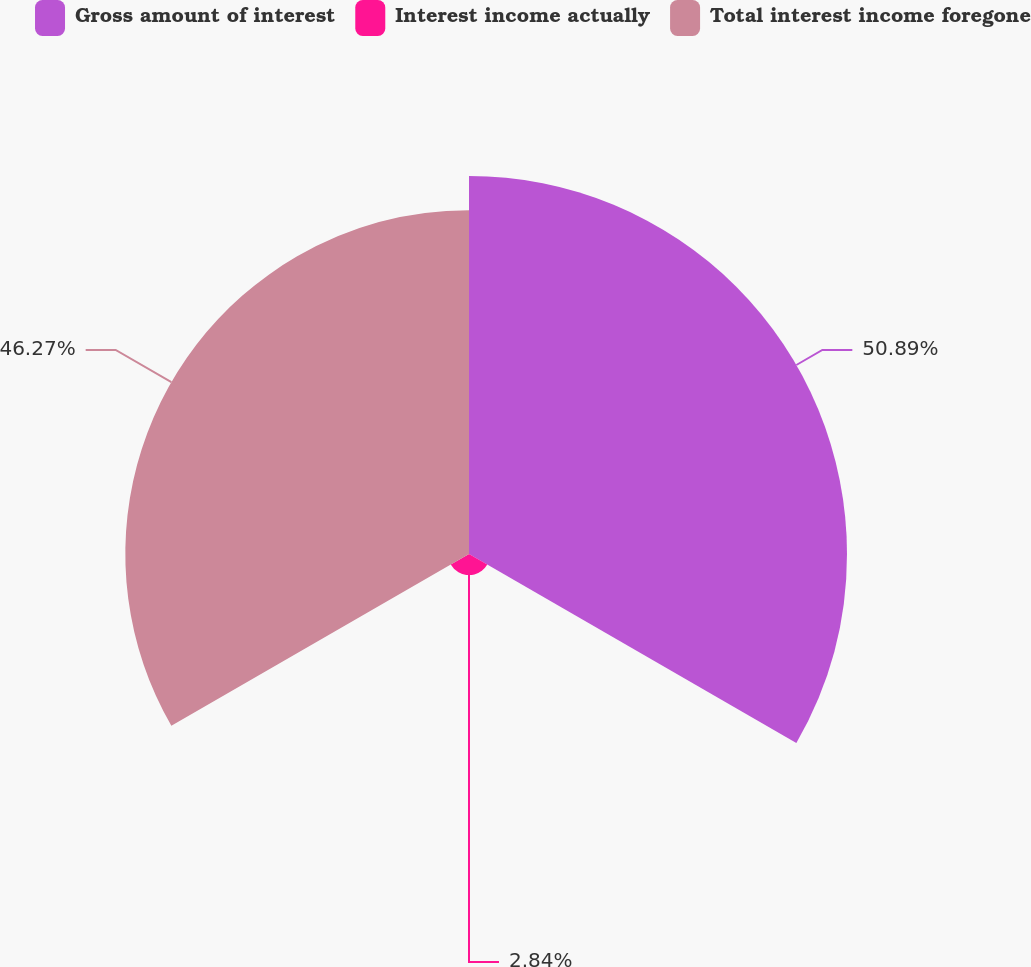<chart> <loc_0><loc_0><loc_500><loc_500><pie_chart><fcel>Gross amount of interest<fcel>Interest income actually<fcel>Total interest income foregone<nl><fcel>50.89%<fcel>2.84%<fcel>46.27%<nl></chart> 